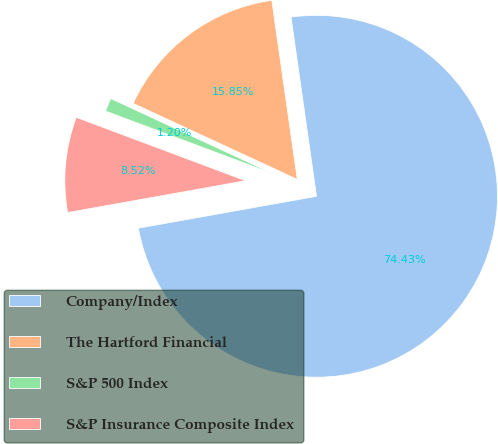<chart> <loc_0><loc_0><loc_500><loc_500><pie_chart><fcel>Company/Index<fcel>The Hartford Financial<fcel>S&P 500 Index<fcel>S&P Insurance Composite Index<nl><fcel>74.44%<fcel>15.85%<fcel>1.2%<fcel>8.52%<nl></chart> 